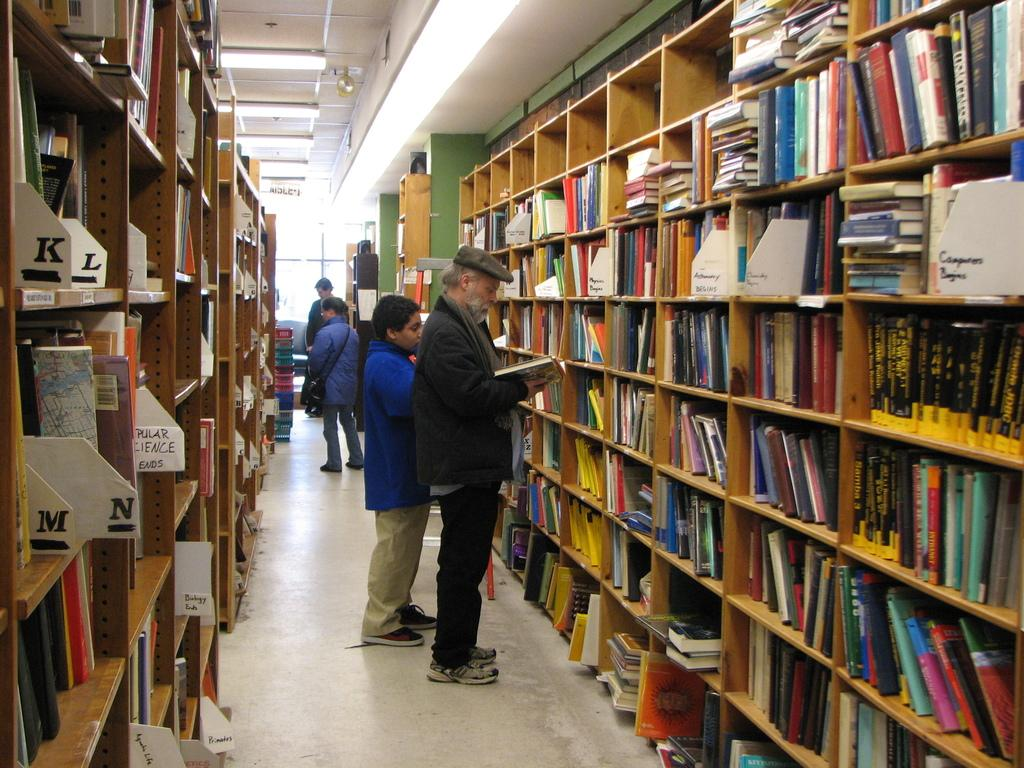<image>
Summarize the visual content of the image. Rows of bookshelves are tagged with letters beginning with K and L on the left side. 